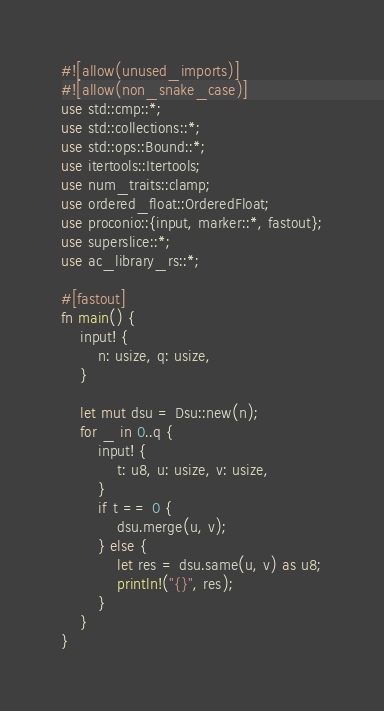<code> <loc_0><loc_0><loc_500><loc_500><_Rust_>#![allow(unused_imports)]
#![allow(non_snake_case)]
use std::cmp::*;
use std::collections::*;
use std::ops::Bound::*;
use itertools::Itertools;
use num_traits::clamp;
use ordered_float::OrderedFloat;
use proconio::{input, marker::*, fastout};
use superslice::*;
use ac_library_rs::*;

#[fastout]
fn main() {
    input! {
        n: usize, q: usize,
    }

    let mut dsu = Dsu::new(n);
    for _ in 0..q {
        input! {
            t: u8, u: usize, v: usize,
        }
        if t == 0 {
            dsu.merge(u, v);
        } else {
            let res = dsu.same(u, v) as u8;
            println!("{}", res);
        }
    }
}
</code> 